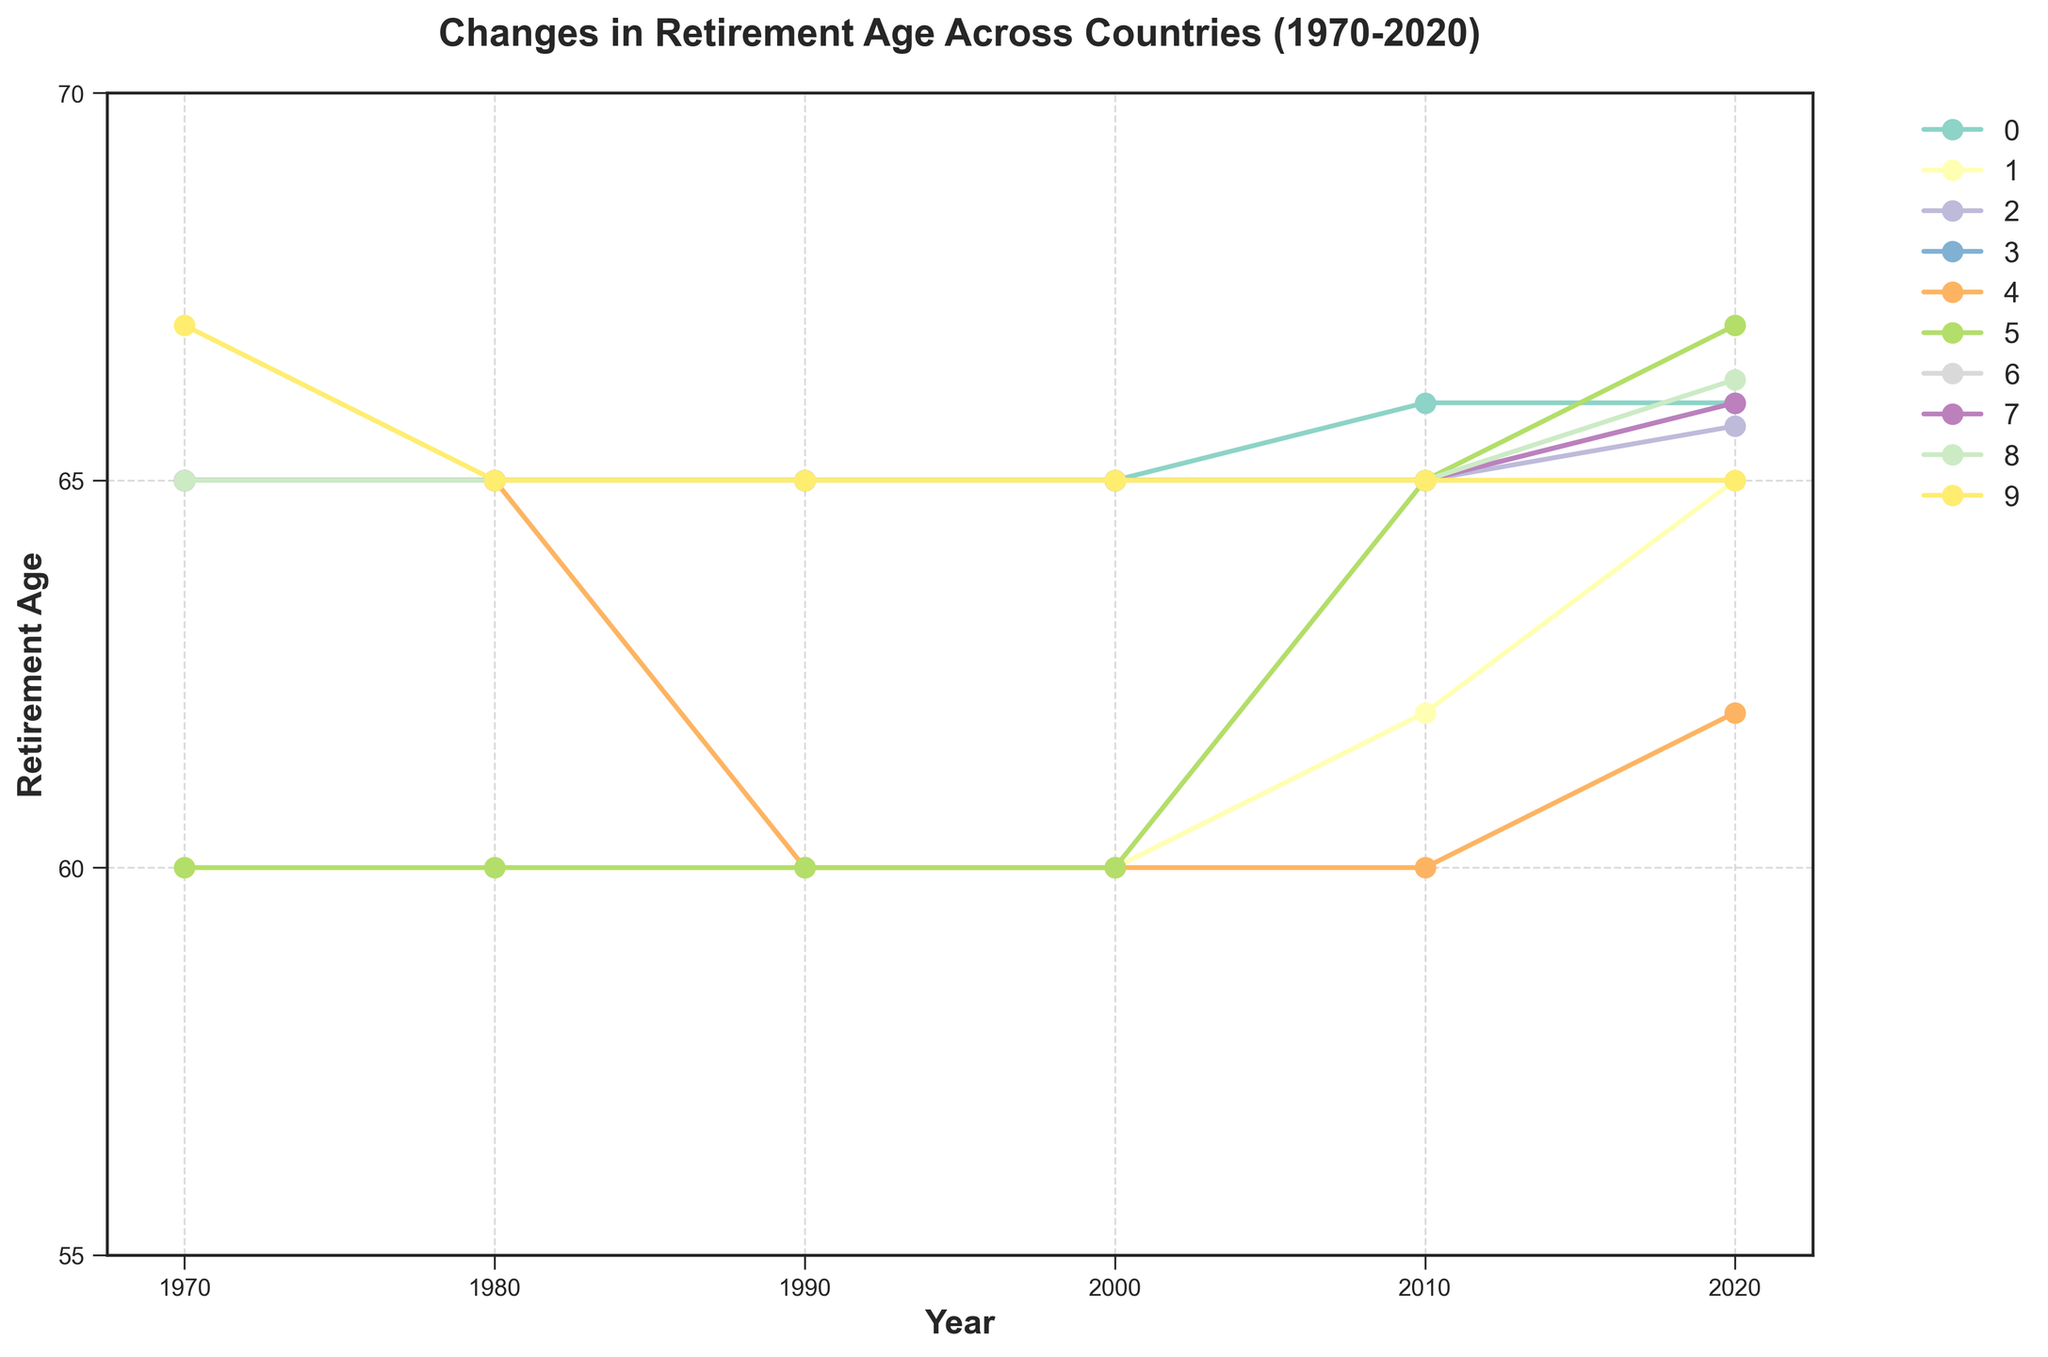Which country had the lowest retirement age in 1970? In 1970, comparing the initial points of each country's line, Japan and Italy both show a retirement age of 60.
Answer: Japan and Italy Which country showed the highest increase in retirement age from 1970 to 2020? By comparing the starting and ending points for each line, Italy increased from 60 to 67, a total increase of 7 years.
Answer: Italy How many countries had a retirement age of 65 in 1990? Observing the points in 1990, the United States, Germany, the United Kingdom, Canada, Australia, Netherlands, Sweden each have a retirement age of 65. This totals 7 countries.
Answer: 7 countries Which country had fluctuations in its retirement age between 1970 and 2020? France shows fluctuations, starting at 65 in 1970, dropping to 60 in 1990, and then rising again to 62 by 2020.
Answer: France Which two countries have identical retirement ages in both 1970 and 2020, but different in between? By looking for identical starting and ending points with variations during the years, Japan and the United Kingdom both start from a different retirement age and align only in 2020; however, none have identical points with variations.
Answer: None Which year saw the most significant change in retirement ages across the countries? Checking the different year segments, the 2010-2020 period shows the greatest variation with noticeable increases in Japan, Germany, Italy, and Netherlands while the others remained stable.
Answer: 2010-2020 What's the average retirement age across all countries in 2020? Adding the retirement ages in 2020 for all countries: (66 + 65 + 65.7 + 66 + 62 + 67 + 65 + 66 + 66.3 + 65) equals 653. The average is 653 / 10 = 65.3
Answer: 65.3 Did any country maintain the same retirement age from 1970 to 2020? By analyzing the straight lines without changes, Canada and Sweden maintained a retirement age of 65 throughout the period.
Answer: Canada and Sweden For which country did the retirement age reach 67 by the end of 2020? Only Italy's data point in 2020 reaches 67.
Answer: Italy Which country lowered its retirement age the most in any one period? France lowered its retirement age from 65 to 60 between 1980 and 1990, a reduction of 5 years.
Answer: France 